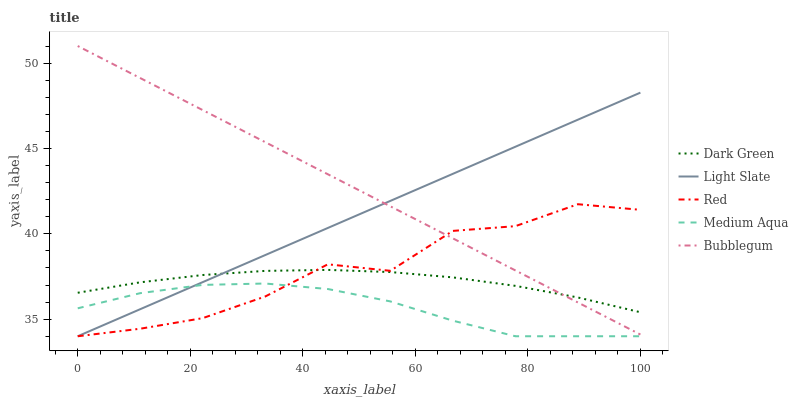Does Medium Aqua have the minimum area under the curve?
Answer yes or no. Yes. Does Bubblegum have the maximum area under the curve?
Answer yes or no. Yes. Does Bubblegum have the minimum area under the curve?
Answer yes or no. No. Does Medium Aqua have the maximum area under the curve?
Answer yes or no. No. Is Bubblegum the smoothest?
Answer yes or no. Yes. Is Red the roughest?
Answer yes or no. Yes. Is Medium Aqua the smoothest?
Answer yes or no. No. Is Medium Aqua the roughest?
Answer yes or no. No. Does Light Slate have the lowest value?
Answer yes or no. Yes. Does Bubblegum have the lowest value?
Answer yes or no. No. Does Bubblegum have the highest value?
Answer yes or no. Yes. Does Medium Aqua have the highest value?
Answer yes or no. No. Is Medium Aqua less than Bubblegum?
Answer yes or no. Yes. Is Dark Green greater than Medium Aqua?
Answer yes or no. Yes. Does Dark Green intersect Light Slate?
Answer yes or no. Yes. Is Dark Green less than Light Slate?
Answer yes or no. No. Is Dark Green greater than Light Slate?
Answer yes or no. No. Does Medium Aqua intersect Bubblegum?
Answer yes or no. No. 